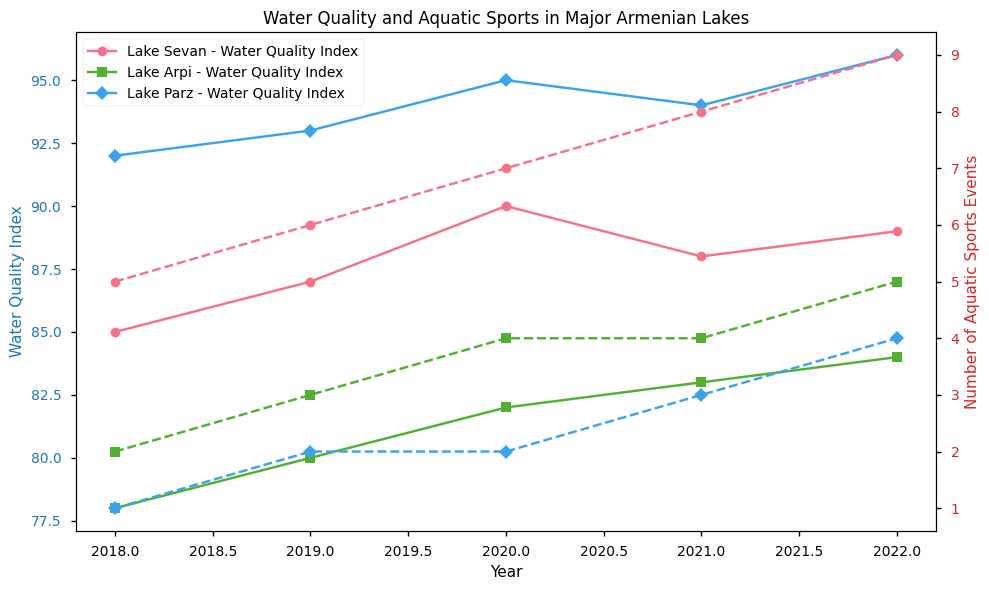Which lake had the highest water quality index in 2022? Look for the data points or lines representing 2022 for all lakes and compare their values for water quality index. Lake Parz has the highest value in 2022.
Answer: Lake Parz Which lake had the most consistent water quality improvement over the years? By examining the year-over-year changes in the water quality index lines, Lake Parz shows a steady increase in its index value each year.
Answer: Lake Parz How did the number of aquatic sports events in Lake Sevan change from 2019 to 2021? Identify the specific data points for Lake Sevan in 2019 and 2021 for the number of aquatic sports events. In 2019 it's 6, and in 2021, it's 8, showing an increase.
Answer: It increased Which lake had the biggest improvement in its water quality index from 2018 to 2022? Compare the differences in water quality index values between 2018 and 2022 for each lake. Lake Parz shows an increase from 92 to 96, the biggest improvement.
Answer: Lake Parz Did any lakes show a decline in water quality index at any point? Observe the lines representing water quality index for any downward slopes. Lake Sevan shows a decline from 2020 to 2021.
Answer: Lake Sevan What is the average number of aquatic sports events held in Lake Arpi from 2018 to 2022? Sum the number of aquatic sports events for Lake Arpi from 2018 to 2022 (2, 3, 4, 4, 5), then divide by the number of years (5). (2+3+4+4+5) / 5 = 18/5 = 3.6
Answer: 3.6 Which lake saw the highest number of aquatic sports events in 2022? Compare the number of aquatic sports events for all lakes in 2022. Lake Sevan had the highest number, 9 events.
Answer: Lake Sevan How did the water quality index of Lake Sevan change over the years? Trace the line corresponding to Lake Sevan's water quality index from 2018 (85), 2019 (87), 2020 (90), 2021 (88), and 2022 (89).
Answer: It fluctuated; increased initially, then decreased and increased again Was the number of aquatic sports events directly correlated with the water quality index for any lake? Check the patterns in the charts of water quality index and number of aquatic sports for each lake. Lake Sevan shows a positive correlation where both values generally increase together.
Answer: Lake Sevan 